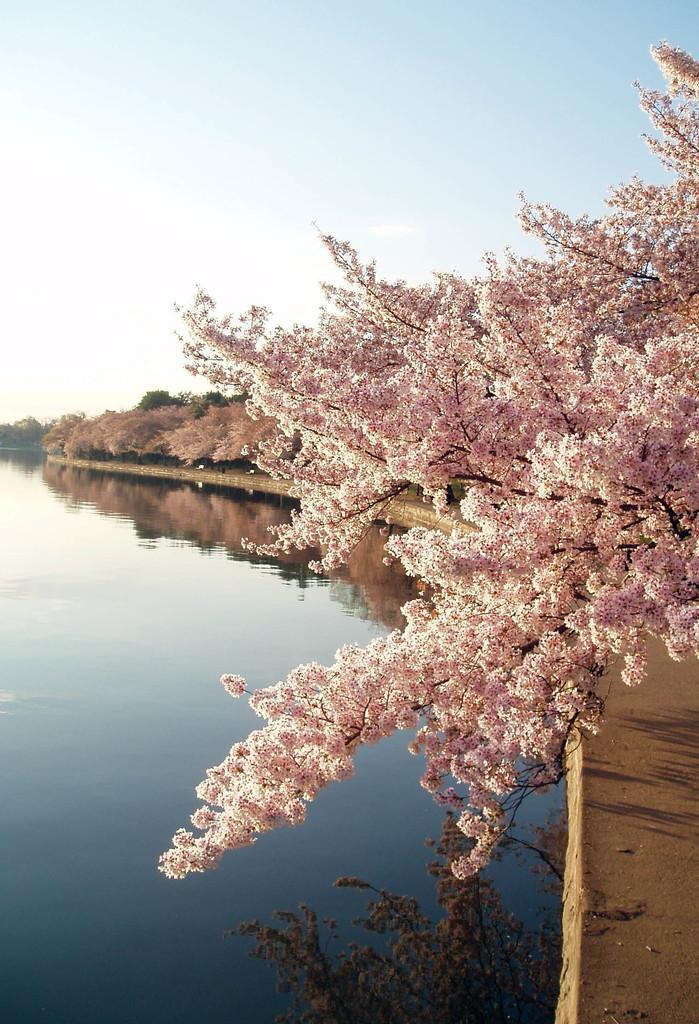How would you summarize this image in a sentence or two? This picture is clicked outside. In the foreground we can see a water body. On the right we can see the flowers and a tree. In the background we can see the sky and some other objects. 